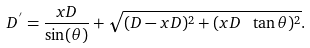Convert formula to latex. <formula><loc_0><loc_0><loc_500><loc_500>D ^ { ^ { \prime } } = \frac { x D } { \sin ( \theta ) } + \sqrt { ( D - x D ) ^ { 2 } + ( x D \ \tan \theta ) ^ { 2 } } .</formula> 